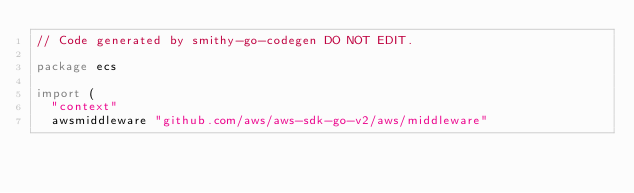Convert code to text. <code><loc_0><loc_0><loc_500><loc_500><_Go_>// Code generated by smithy-go-codegen DO NOT EDIT.

package ecs

import (
	"context"
	awsmiddleware "github.com/aws/aws-sdk-go-v2/aws/middleware"</code> 